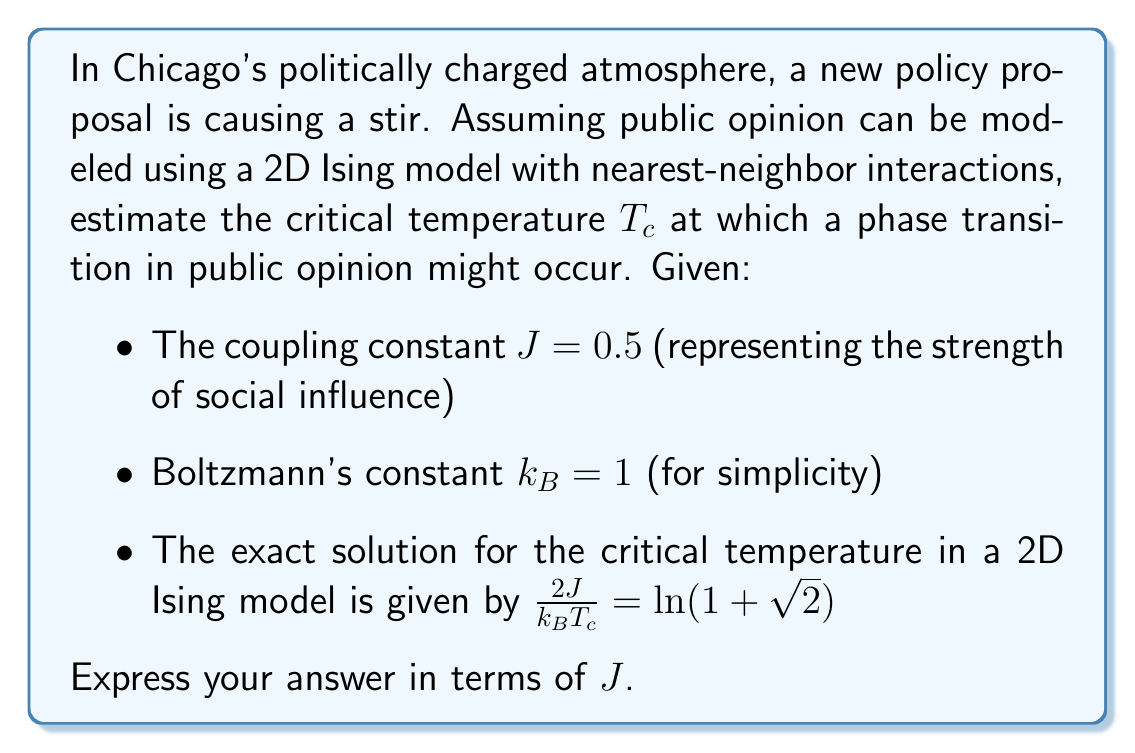Give your solution to this math problem. Let's approach this step-by-step:

1) We start with the exact solution for the critical temperature in a 2D Ising model:

   $$\frac{2J}{k_B T_c} = \ln(1 + \sqrt{2})$$

2) We're given that $k_B = 1$ for simplicity, so we can simplify this to:

   $$\frac{2J}{T_c} = \ln(1 + \sqrt{2})$$

3) To solve for $T_c$, we need to isolate it:

   $$T_c = \frac{2J}{\ln(1 + \sqrt{2})}$$

4) We're asked to express the answer in terms of $J$, so this is our final form.

5) If we wanted to calculate a numerical value, we could substitute $J = 0.5$:

   $$T_c = \frac{2(0.5)}{\ln(1 + \sqrt{2})} \approx 1.13$$

However, the question asks for the answer in terms of $J$, so we'll leave it in its symbolic form.
Answer: $T_c = \frac{2J}{\ln(1 + \sqrt{2})}$ 